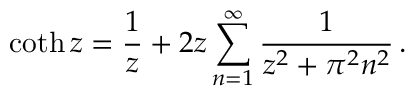Convert formula to latex. <formula><loc_0><loc_0><loc_500><loc_500>\coth z = \frac { 1 } { z } + 2 z \sum _ { n = 1 } ^ { \infty } \frac { 1 } { z ^ { 2 } + \pi ^ { 2 } n ^ { 2 } } \, { . }</formula> 